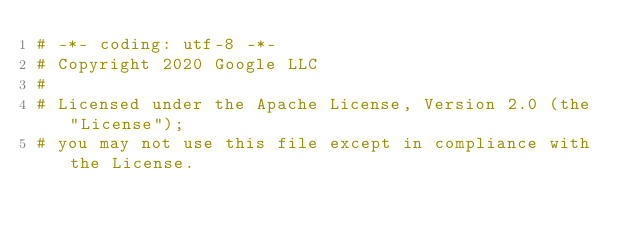Convert code to text. <code><loc_0><loc_0><loc_500><loc_500><_Python_># -*- coding: utf-8 -*-
# Copyright 2020 Google LLC
#
# Licensed under the Apache License, Version 2.0 (the "License");
# you may not use this file except in compliance with the License.</code> 